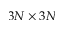<formula> <loc_0><loc_0><loc_500><loc_500>3 N \times 3 N</formula> 